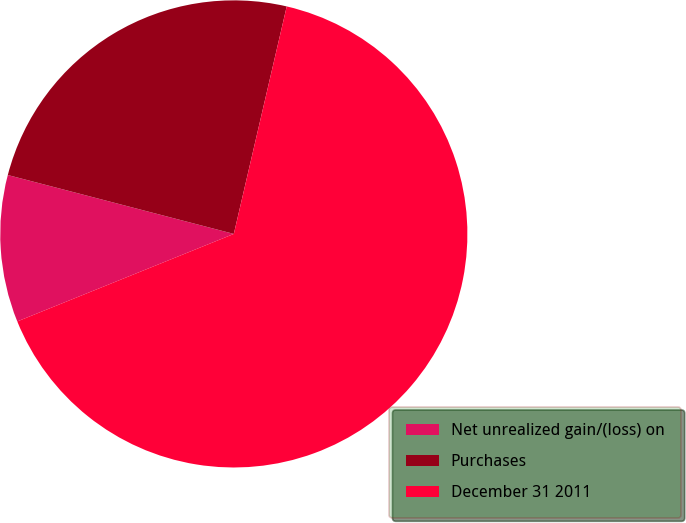Convert chart to OTSL. <chart><loc_0><loc_0><loc_500><loc_500><pie_chart><fcel>Net unrealized gain/(loss) on<fcel>Purchases<fcel>December 31 2011<nl><fcel>10.17%<fcel>24.58%<fcel>65.25%<nl></chart> 